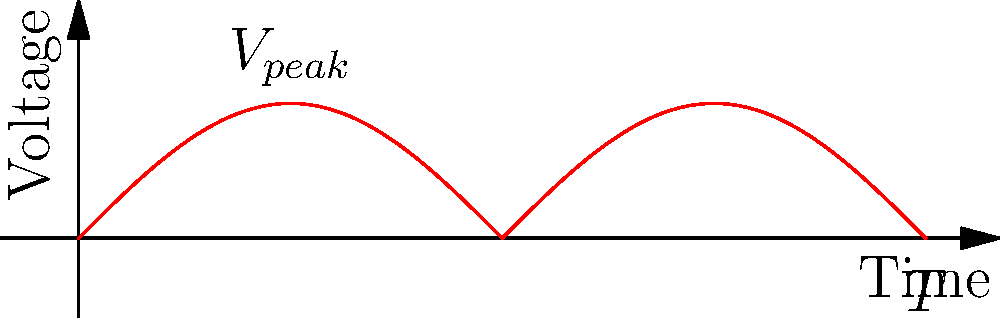In the context of divine design in electrical systems, analyze the waveform shown on the oscilloscope display. If the period $T$ of the original AC signal is 20 ms, what is the frequency of the rectified signal? Let's approach this step-by-step, reflecting on the perfection of God's creation as manifested in electrical phenomena:

1) First, observe that the waveform shown is a full-wave rectified sine wave. This transformation from AC to rectified DC is reminiscent of the spiritual transformation in conversion.

2) In a full-wave rectified signal, the negative half-cycles are "flipped" to become positive, doubling the frequency of the original signal. This mirrors how in faith, even our struggles can be turned into positive growth.

3) We're given that the period $T$ of the original AC signal is 20 ms. 

4) Recall that frequency $f$ is the inverse of period: $f = \frac{1}{T}$

5) For the original signal:
   $f_{original} = \frac{1}{T} = \frac{1}{20 \text{ ms}} = 50 \text{ Hz}$

6) As the rectification doubles the frequency, the frequency of the rectified signal is:
   $f_{rectified} = 2 \times f_{original} = 2 \times 50 \text{ Hz} = 100 \text{ Hz}$

Just as this signal has been transformed and its frequency doubled, so too can our faith be strengthened and our spiritual "frequency" elevated through conversion and devotion.
Answer: 100 Hz 